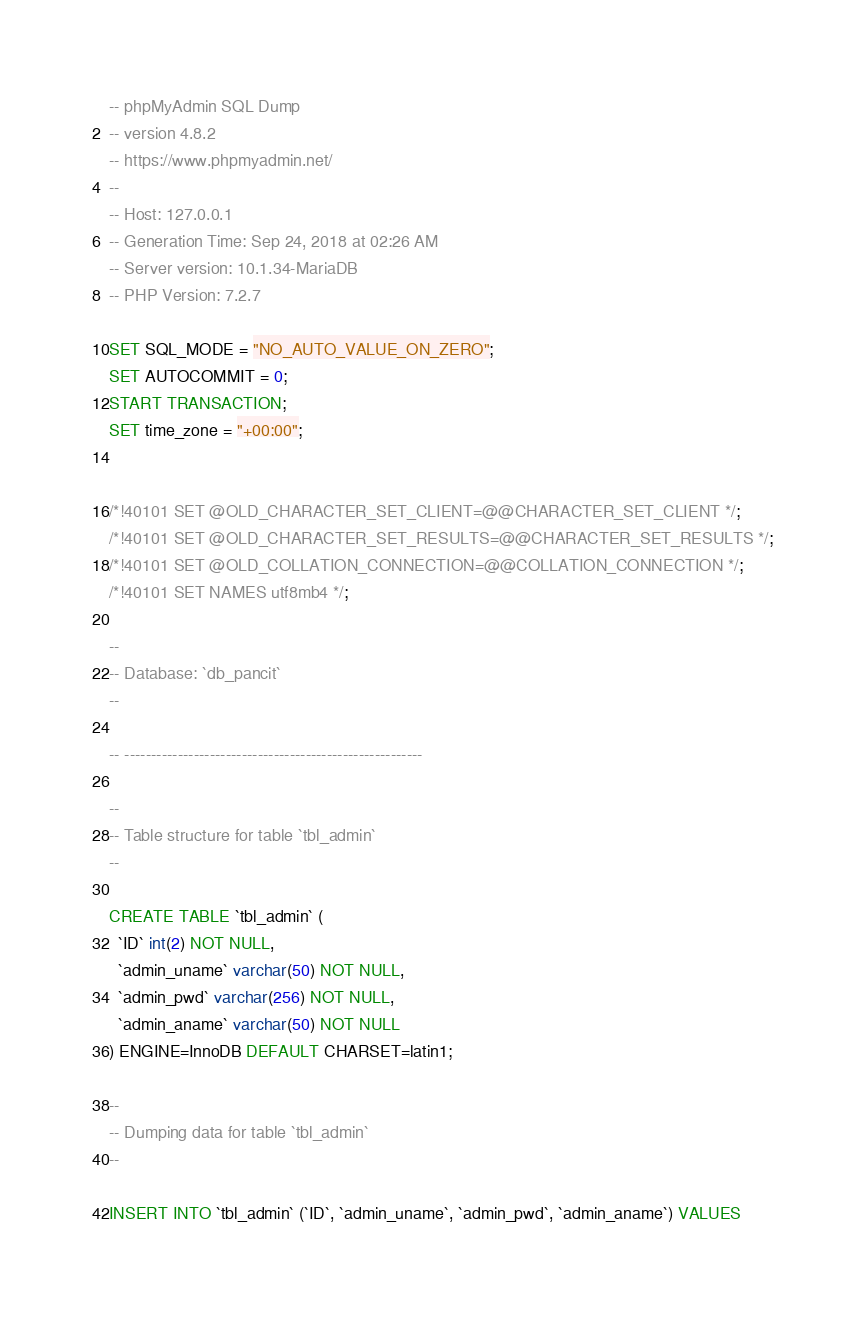Convert code to text. <code><loc_0><loc_0><loc_500><loc_500><_SQL_>-- phpMyAdmin SQL Dump
-- version 4.8.2
-- https://www.phpmyadmin.net/
--
-- Host: 127.0.0.1
-- Generation Time: Sep 24, 2018 at 02:26 AM
-- Server version: 10.1.34-MariaDB
-- PHP Version: 7.2.7

SET SQL_MODE = "NO_AUTO_VALUE_ON_ZERO";
SET AUTOCOMMIT = 0;
START TRANSACTION;
SET time_zone = "+00:00";


/*!40101 SET @OLD_CHARACTER_SET_CLIENT=@@CHARACTER_SET_CLIENT */;
/*!40101 SET @OLD_CHARACTER_SET_RESULTS=@@CHARACTER_SET_RESULTS */;
/*!40101 SET @OLD_COLLATION_CONNECTION=@@COLLATION_CONNECTION */;
/*!40101 SET NAMES utf8mb4 */;

--
-- Database: `db_pancit`
--

-- --------------------------------------------------------

--
-- Table structure for table `tbl_admin`
--

CREATE TABLE `tbl_admin` (
  `ID` int(2) NOT NULL,
  `admin_uname` varchar(50) NOT NULL,
  `admin_pwd` varchar(256) NOT NULL,
  `admin_aname` varchar(50) NOT NULL
) ENGINE=InnoDB DEFAULT CHARSET=latin1;

--
-- Dumping data for table `tbl_admin`
--

INSERT INTO `tbl_admin` (`ID`, `admin_uname`, `admin_pwd`, `admin_aname`) VALUES</code> 